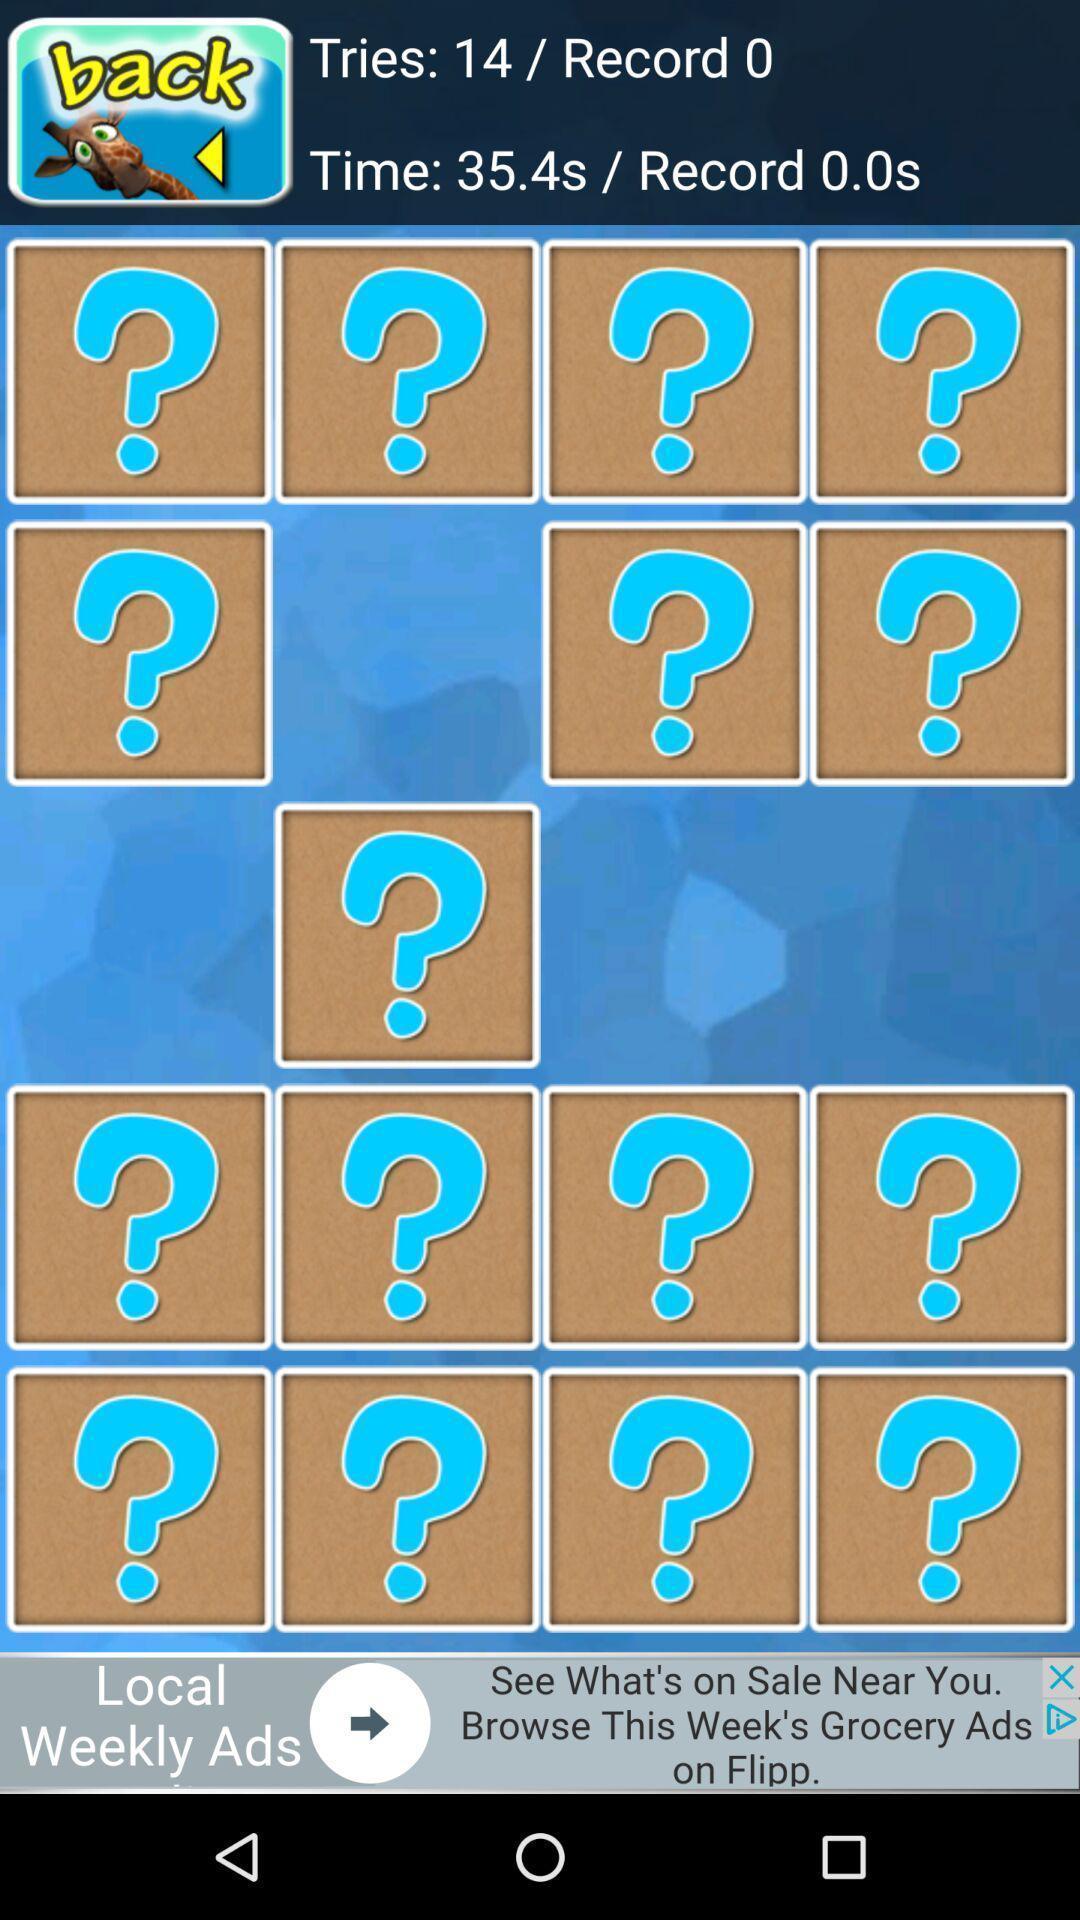What is the overall content of this screenshot? Screen showing time and number of tries of a game. 